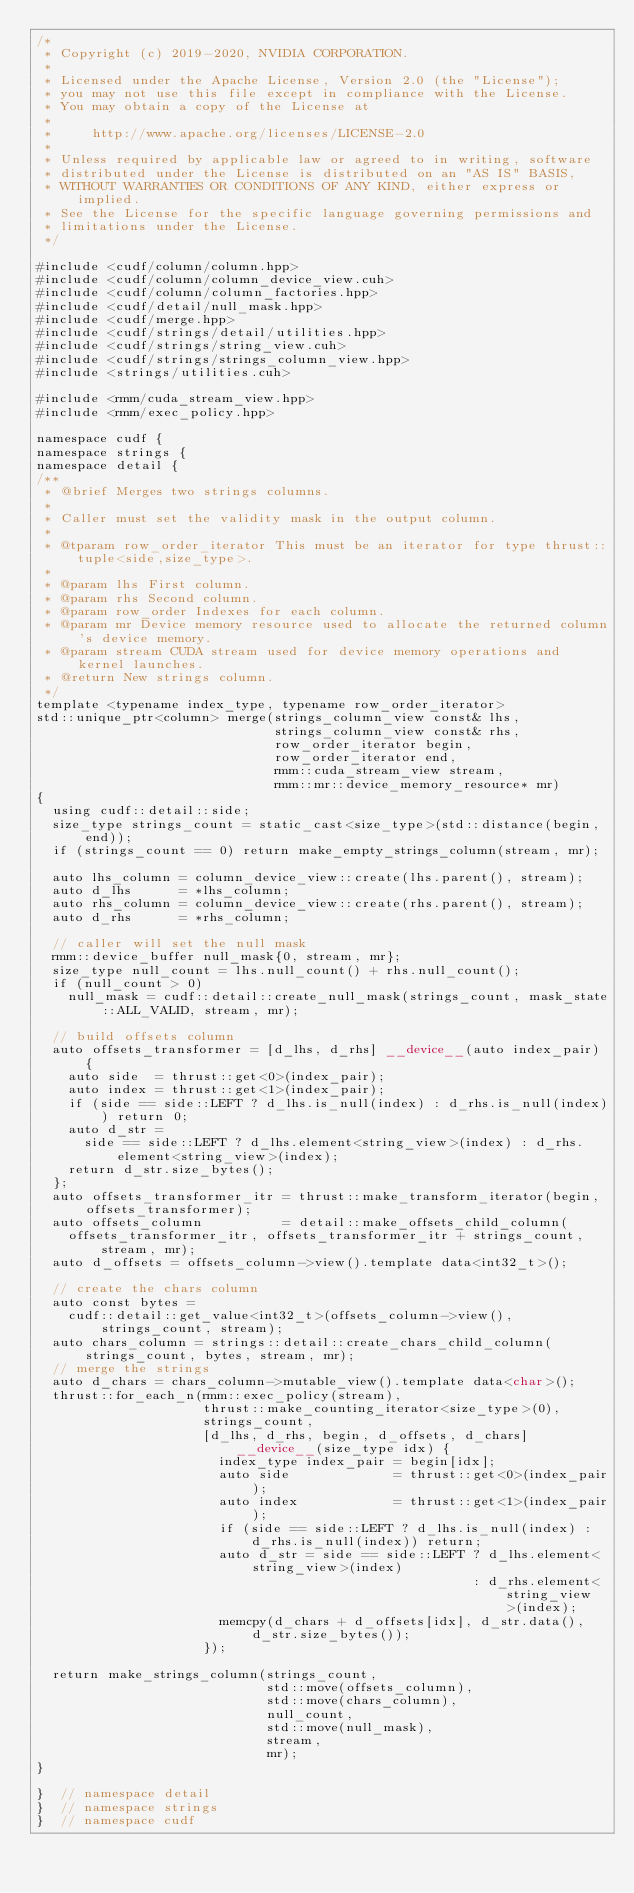Convert code to text. <code><loc_0><loc_0><loc_500><loc_500><_Cuda_>/*
 * Copyright (c) 2019-2020, NVIDIA CORPORATION.
 *
 * Licensed under the Apache License, Version 2.0 (the "License");
 * you may not use this file except in compliance with the License.
 * You may obtain a copy of the License at
 *
 *     http://www.apache.org/licenses/LICENSE-2.0
 *
 * Unless required by applicable law or agreed to in writing, software
 * distributed under the License is distributed on an "AS IS" BASIS,
 * WITHOUT WARRANTIES OR CONDITIONS OF ANY KIND, either express or implied.
 * See the License for the specific language governing permissions and
 * limitations under the License.
 */

#include <cudf/column/column.hpp>
#include <cudf/column/column_device_view.cuh>
#include <cudf/column/column_factories.hpp>
#include <cudf/detail/null_mask.hpp>
#include <cudf/merge.hpp>
#include <cudf/strings/detail/utilities.hpp>
#include <cudf/strings/string_view.cuh>
#include <cudf/strings/strings_column_view.hpp>
#include <strings/utilities.cuh>

#include <rmm/cuda_stream_view.hpp>
#include <rmm/exec_policy.hpp>

namespace cudf {
namespace strings {
namespace detail {
/**
 * @brief Merges two strings columns.
 *
 * Caller must set the validity mask in the output column.
 *
 * @tparam row_order_iterator This must be an iterator for type thrust::tuple<side,size_type>.
 *
 * @param lhs First column.
 * @param rhs Second column.
 * @param row_order Indexes for each column.
 * @param mr Device memory resource used to allocate the returned column's device memory.
 * @param stream CUDA stream used for device memory operations and kernel launches.
 * @return New strings column.
 */
template <typename index_type, typename row_order_iterator>
std::unique_ptr<column> merge(strings_column_view const& lhs,
                              strings_column_view const& rhs,
                              row_order_iterator begin,
                              row_order_iterator end,
                              rmm::cuda_stream_view stream,
                              rmm::mr::device_memory_resource* mr)
{
  using cudf::detail::side;
  size_type strings_count = static_cast<size_type>(std::distance(begin, end));
  if (strings_count == 0) return make_empty_strings_column(stream, mr);

  auto lhs_column = column_device_view::create(lhs.parent(), stream);
  auto d_lhs      = *lhs_column;
  auto rhs_column = column_device_view::create(rhs.parent(), stream);
  auto d_rhs      = *rhs_column;

  // caller will set the null mask
  rmm::device_buffer null_mask{0, stream, mr};
  size_type null_count = lhs.null_count() + rhs.null_count();
  if (null_count > 0)
    null_mask = cudf::detail::create_null_mask(strings_count, mask_state::ALL_VALID, stream, mr);

  // build offsets column
  auto offsets_transformer = [d_lhs, d_rhs] __device__(auto index_pair) {
    auto side  = thrust::get<0>(index_pair);
    auto index = thrust::get<1>(index_pair);
    if (side == side::LEFT ? d_lhs.is_null(index) : d_rhs.is_null(index)) return 0;
    auto d_str =
      side == side::LEFT ? d_lhs.element<string_view>(index) : d_rhs.element<string_view>(index);
    return d_str.size_bytes();
  };
  auto offsets_transformer_itr = thrust::make_transform_iterator(begin, offsets_transformer);
  auto offsets_column          = detail::make_offsets_child_column(
    offsets_transformer_itr, offsets_transformer_itr + strings_count, stream, mr);
  auto d_offsets = offsets_column->view().template data<int32_t>();

  // create the chars column
  auto const bytes =
    cudf::detail::get_value<int32_t>(offsets_column->view(), strings_count, stream);
  auto chars_column = strings::detail::create_chars_child_column(strings_count, bytes, stream, mr);
  // merge the strings
  auto d_chars = chars_column->mutable_view().template data<char>();
  thrust::for_each_n(rmm::exec_policy(stream),
                     thrust::make_counting_iterator<size_type>(0),
                     strings_count,
                     [d_lhs, d_rhs, begin, d_offsets, d_chars] __device__(size_type idx) {
                       index_type index_pair = begin[idx];
                       auto side             = thrust::get<0>(index_pair);
                       auto index            = thrust::get<1>(index_pair);
                       if (side == side::LEFT ? d_lhs.is_null(index) : d_rhs.is_null(index)) return;
                       auto d_str = side == side::LEFT ? d_lhs.element<string_view>(index)
                                                       : d_rhs.element<string_view>(index);
                       memcpy(d_chars + d_offsets[idx], d_str.data(), d_str.size_bytes());
                     });

  return make_strings_column(strings_count,
                             std::move(offsets_column),
                             std::move(chars_column),
                             null_count,
                             std::move(null_mask),
                             stream,
                             mr);
}

}  // namespace detail
}  // namespace strings
}  // namespace cudf
</code> 